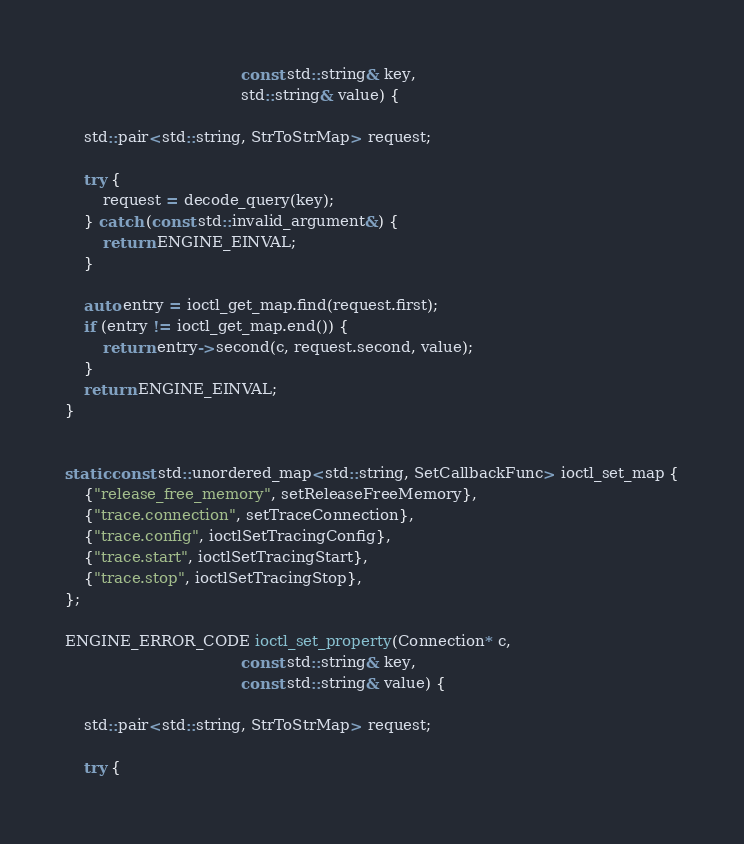<code> <loc_0><loc_0><loc_500><loc_500><_C++_>                                     const std::string& key,
                                     std::string& value) {

    std::pair<std::string, StrToStrMap> request;

    try {
        request = decode_query(key);
    } catch (const std::invalid_argument&) {
        return ENGINE_EINVAL;
    }

    auto entry = ioctl_get_map.find(request.first);
    if (entry != ioctl_get_map.end()) {
        return entry->second(c, request.second, value);
    }
    return ENGINE_EINVAL;
}


static const std::unordered_map<std::string, SetCallbackFunc> ioctl_set_map {
    {"release_free_memory", setReleaseFreeMemory},
    {"trace.connection", setTraceConnection},
    {"trace.config", ioctlSetTracingConfig},
    {"trace.start", ioctlSetTracingStart},
    {"trace.stop", ioctlSetTracingStop},
};

ENGINE_ERROR_CODE ioctl_set_property(Connection* c,
                                     const std::string& key,
                                     const std::string& value) {

    std::pair<std::string, StrToStrMap> request;

    try {</code> 